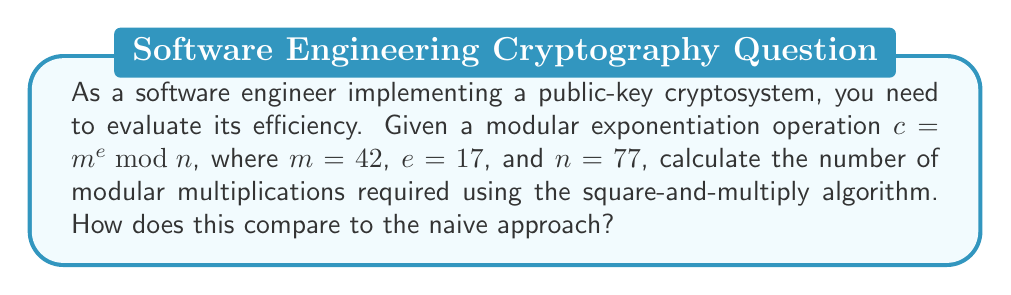What is the answer to this math problem? To evaluate the efficiency of the modular exponentiation $c = m^e \bmod n$ using the square-and-multiply algorithm:

1. Convert the exponent $e = 17$ to binary: $17_{10} = 10001_2$

2. Initialize: result = 1, base = 42

3. Process bits from left to right:
   - For each bit:
     - Square the result: result = result^2 mod 77
   - If the bit is 1:
     - Multiply result by base: result = result * base mod 77

4. Count operations:
   - Number of bits in $e$: 5
   - Number of squaring operations: 4 (one less than the number of bits)
   - Number of multiplications: 2 (number of 1's in the binary representation, excluding the leftmost 1)

5. Total modular multiplications: 4 + 2 = 6

6. Compare to naive approach:
   - Naive approach would require 16 multiplications (one less than the exponent)
   - Square-and-multiply requires only 6 multiplications

7. Efficiency improvement:
   - (16 - 6) / 16 * 100 ≈ 62.5% reduction in multiplications
Answer: 6 multiplications; 62.5% more efficient than naive approach 